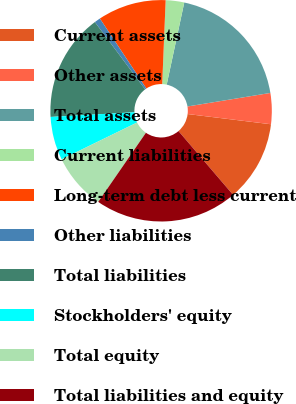<chart> <loc_0><loc_0><loc_500><loc_500><pie_chart><fcel>Current assets<fcel>Other assets<fcel>Total assets<fcel>Current liabilities<fcel>Long-term debt less current<fcel>Other liabilities<fcel>Total liabilities<fcel>Stockholders' equity<fcel>Total equity<fcel>Total liabilities and equity<nl><fcel>11.79%<fcel>4.52%<fcel>19.07%<fcel>2.7%<fcel>9.98%<fcel>0.88%<fcel>15.68%<fcel>6.34%<fcel>8.16%<fcel>20.88%<nl></chart> 